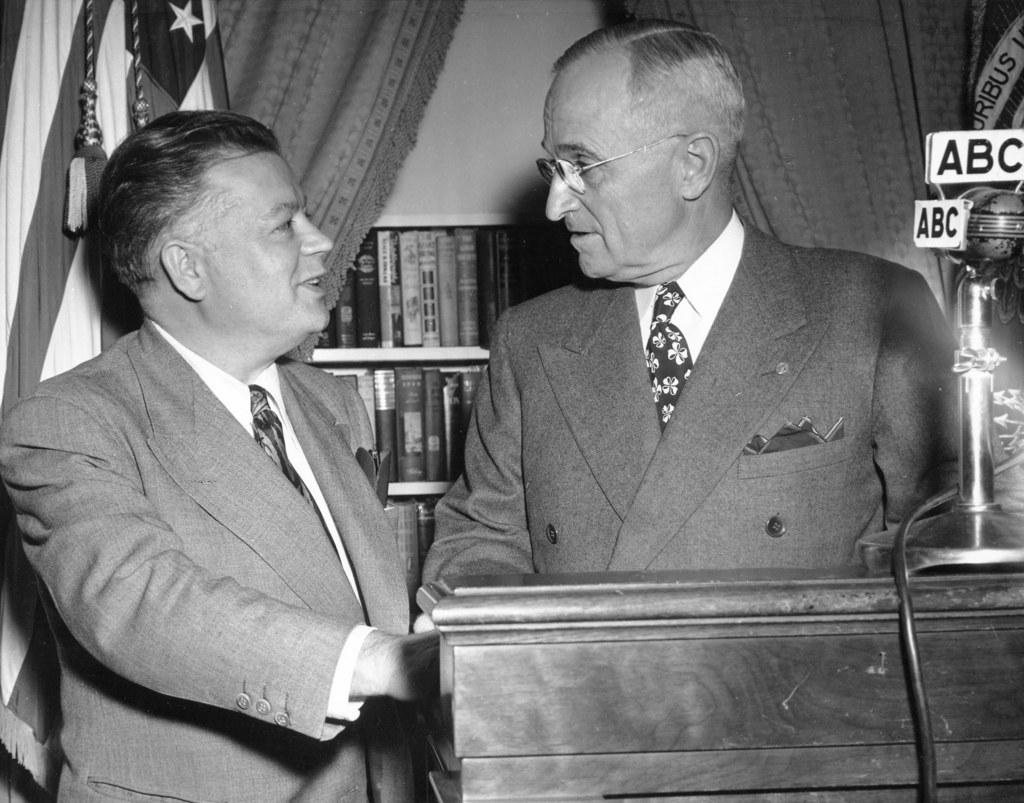What broadcast station is shown on the microphone?
Provide a short and direct response. Abc. 